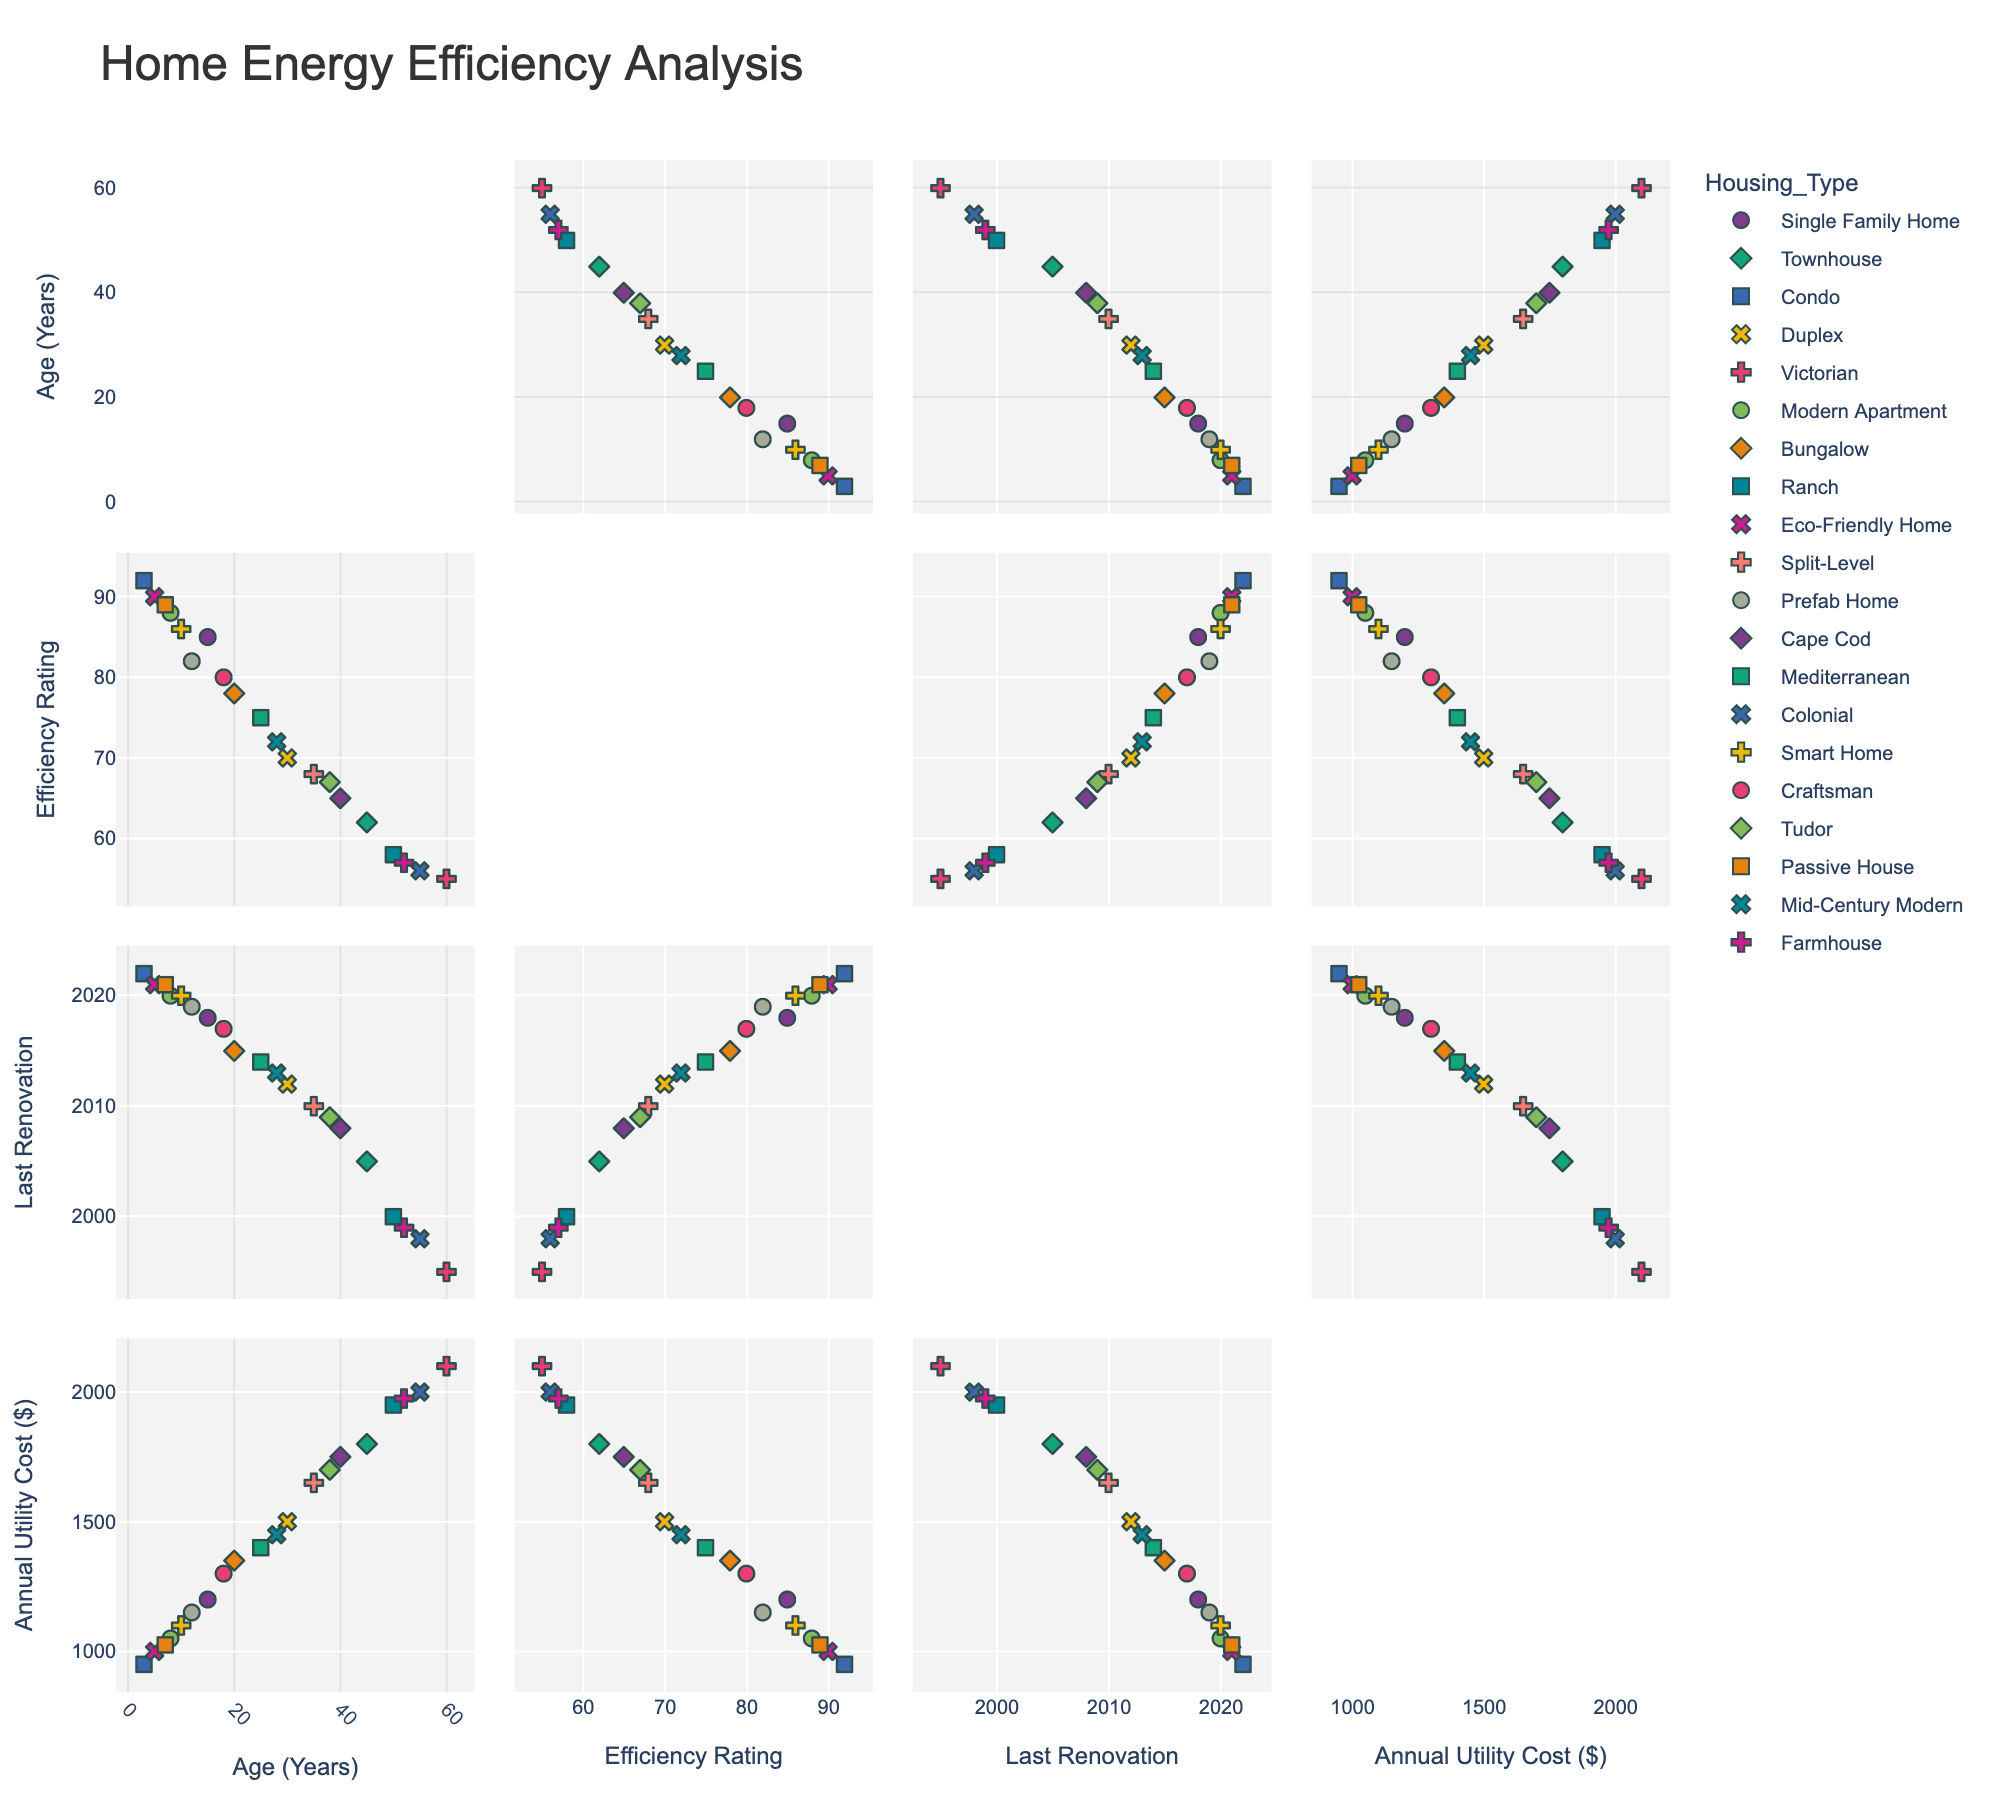What's the title of the figure? The title of a figure is usually located at the top center. In this case, the title is "Distribution of Art Galleries in Texas," which is clearly written at the top of the figure.
Answer: Distribution of Art Galleries in Texas How many subplots are there in the figure? The figure is divided into sections, and there are four distinct subplots as indicated by the layout and different shaded titles of each subplot.
Answer: 4 Which city has the highest number of galleries? In the subplot "Population vs. Number of Galleries," by looking at the data points with hover information, Houston shows the highest number of galleries.
Answer: Houston Is there a strong positive correlation between population and the number of galleries? Observing the "Population vs. Number of Galleries" subplot, although there is generally an upward trend, the relationship doesn't appear to be strictly linear, indicating a weak to moderate positive correlation. Furthermore, the size of the bubbles varies, which impacts the perception of correlation strength.
Answer: Weak to moderate positive correlation What is the average size of galleries in Marfa? By looking at the data in the "Population vs. Average Gallery Size" subplot, hovering over Marfa's data point shows an average gallery size of 1800 sqft.
Answer: 1800 sqft Which city has the smallest average gallery size? In the "Population vs. Average Gallery Size" subplot, San Angelo can be seen with the smallest bubble size, indicating the smallest average gallery size at 1400 sqft.
Answer: San Angelo Which artistic focus has the largest number of galleries? In the "Artistic Focus Distribution" subplot, the largest bubble size corresponds to Contemporary art, indicating the most galleries are focusing on this artistic type.
Answer: Contemporary What is the relationship between the number of galleries and average gallery size? Looking at the "Number of Galleries vs. Average Gallery Size" subplot, there isn't a clear consistent trend. The bubble sizes show varied gallery sizes regardless of the number of galleries in the city.
Answer: No clear relationship Among the cities with a population over 1 million, which one has the smallest number of galleries? By observing the "Population vs. Number of Galleries" subplot, San Antonio, with a population over 1 million, has fewer galleries compared to Houston and Dallas.
Answer: San Antonio Which cities have a primary artistic focus on regional styles like Southwestern or Western art? By observing the hover text in the "Artistic Focus Distribution" subplot, San Antonio focuses on Southwestern art, and Fort Worth focuses on Western art.
Answer: San Antonio and Fort Worth 